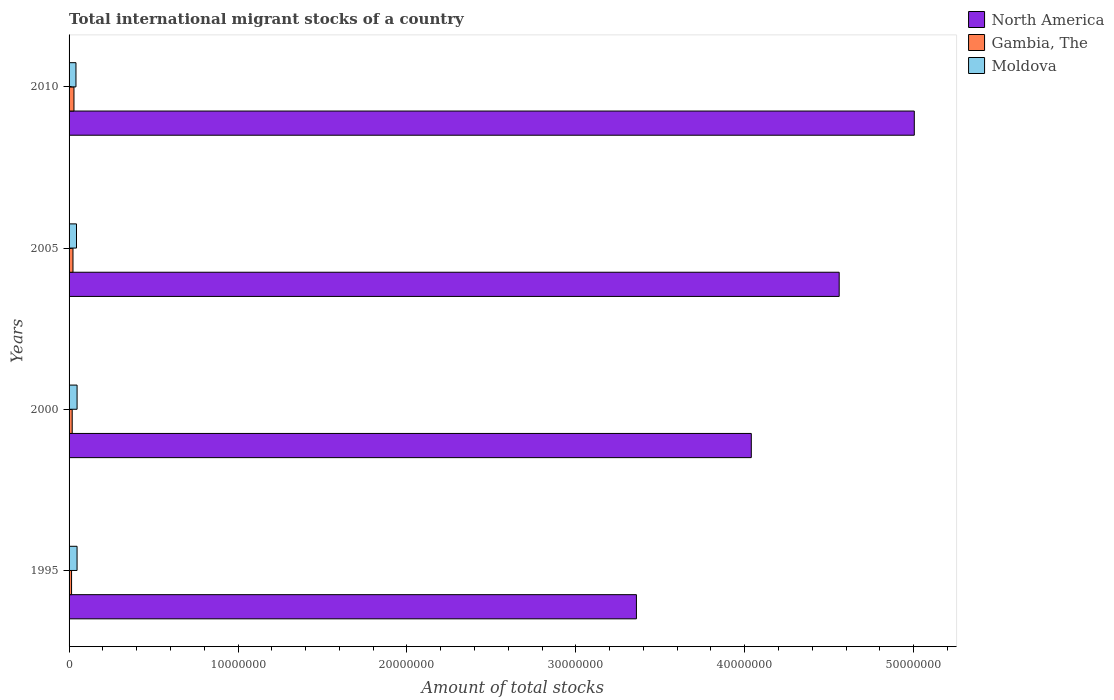How many different coloured bars are there?
Offer a terse response. 3. How many groups of bars are there?
Keep it short and to the point. 4. Are the number of bars per tick equal to the number of legend labels?
Your response must be concise. Yes. Are the number of bars on each tick of the Y-axis equal?
Your response must be concise. Yes. How many bars are there on the 3rd tick from the top?
Ensure brevity in your answer.  3. How many bars are there on the 2nd tick from the bottom?
Provide a short and direct response. 3. In how many cases, is the number of bars for a given year not equal to the number of legend labels?
Keep it short and to the point. 0. What is the amount of total stocks in in Moldova in 2000?
Your answer should be very brief. 4.74e+05. Across all years, what is the maximum amount of total stocks in in North America?
Your answer should be very brief. 5.00e+07. Across all years, what is the minimum amount of total stocks in in Moldova?
Provide a short and direct response. 4.08e+05. In which year was the amount of total stocks in in Gambia, The minimum?
Your response must be concise. 1995. What is the total amount of total stocks in in Moldova in the graph?
Keep it short and to the point. 1.80e+06. What is the difference between the amount of total stocks in in North America in 2005 and that in 2010?
Make the answer very short. -4.45e+06. What is the difference between the amount of total stocks in in Gambia, The in 2005 and the amount of total stocks in in Moldova in 2000?
Keep it short and to the point. -2.43e+05. What is the average amount of total stocks in in Moldova per year?
Your answer should be compact. 4.49e+05. In the year 2000, what is the difference between the amount of total stocks in in Gambia, The and amount of total stocks in in North America?
Your answer should be compact. -4.02e+07. What is the ratio of the amount of total stocks in in North America in 2000 to that in 2005?
Provide a short and direct response. 0.89. What is the difference between the highest and the second highest amount of total stocks in in North America?
Your response must be concise. 4.45e+06. What is the difference between the highest and the lowest amount of total stocks in in Moldova?
Offer a very short reply. 6.61e+04. What does the 2nd bar from the top in 2010 represents?
Your answer should be compact. Gambia, The. What does the 2nd bar from the bottom in 2010 represents?
Ensure brevity in your answer.  Gambia, The. How many bars are there?
Your response must be concise. 12. What is the difference between two consecutive major ticks on the X-axis?
Offer a terse response. 1.00e+07. Does the graph contain any zero values?
Ensure brevity in your answer.  No. Does the graph contain grids?
Keep it short and to the point. No. What is the title of the graph?
Keep it short and to the point. Total international migrant stocks of a country. Does "Iraq" appear as one of the legend labels in the graph?
Ensure brevity in your answer.  No. What is the label or title of the X-axis?
Keep it short and to the point. Amount of total stocks. What is the Amount of total stocks in North America in 1995?
Give a very brief answer. 3.36e+07. What is the Amount of total stocks in Gambia, The in 1995?
Provide a short and direct response. 1.48e+05. What is the Amount of total stocks in Moldova in 1995?
Keep it short and to the point. 4.73e+05. What is the Amount of total stocks in North America in 2000?
Your answer should be compact. 4.04e+07. What is the Amount of total stocks of Gambia, The in 2000?
Provide a succinct answer. 1.85e+05. What is the Amount of total stocks of Moldova in 2000?
Ensure brevity in your answer.  4.74e+05. What is the Amount of total stocks of North America in 2005?
Your answer should be compact. 4.56e+07. What is the Amount of total stocks of Gambia, The in 2005?
Provide a succinct answer. 2.32e+05. What is the Amount of total stocks of Moldova in 2005?
Your answer should be compact. 4.40e+05. What is the Amount of total stocks in North America in 2010?
Your answer should be compact. 5.00e+07. What is the Amount of total stocks of Gambia, The in 2010?
Your answer should be very brief. 2.90e+05. What is the Amount of total stocks of Moldova in 2010?
Offer a very short reply. 4.08e+05. Across all years, what is the maximum Amount of total stocks in North America?
Your answer should be compact. 5.00e+07. Across all years, what is the maximum Amount of total stocks in Gambia, The?
Ensure brevity in your answer.  2.90e+05. Across all years, what is the maximum Amount of total stocks in Moldova?
Your answer should be compact. 4.74e+05. Across all years, what is the minimum Amount of total stocks in North America?
Provide a succinct answer. 3.36e+07. Across all years, what is the minimum Amount of total stocks in Gambia, The?
Offer a terse response. 1.48e+05. Across all years, what is the minimum Amount of total stocks of Moldova?
Make the answer very short. 4.08e+05. What is the total Amount of total stocks of North America in the graph?
Your response must be concise. 1.70e+08. What is the total Amount of total stocks in Gambia, The in the graph?
Provide a succinct answer. 8.55e+05. What is the total Amount of total stocks in Moldova in the graph?
Your response must be concise. 1.80e+06. What is the difference between the Amount of total stocks in North America in 1995 and that in 2000?
Offer a terse response. -6.80e+06. What is the difference between the Amount of total stocks in Gambia, The in 1995 and that in 2000?
Keep it short and to the point. -3.72e+04. What is the difference between the Amount of total stocks in Moldova in 1995 and that in 2000?
Give a very brief answer. -1500. What is the difference between the Amount of total stocks of North America in 1995 and that in 2005?
Your response must be concise. -1.20e+07. What is the difference between the Amount of total stocks in Gambia, The in 1995 and that in 2005?
Your answer should be compact. -8.39e+04. What is the difference between the Amount of total stocks in Moldova in 1995 and that in 2005?
Ensure brevity in your answer.  3.28e+04. What is the difference between the Amount of total stocks in North America in 1995 and that in 2010?
Provide a short and direct response. -1.64e+07. What is the difference between the Amount of total stocks of Gambia, The in 1995 and that in 2010?
Provide a short and direct response. -1.42e+05. What is the difference between the Amount of total stocks of Moldova in 1995 and that in 2010?
Make the answer very short. 6.46e+04. What is the difference between the Amount of total stocks in North America in 2000 and that in 2005?
Keep it short and to the point. -5.20e+06. What is the difference between the Amount of total stocks of Gambia, The in 2000 and that in 2005?
Offer a very short reply. -4.66e+04. What is the difference between the Amount of total stocks in Moldova in 2000 and that in 2005?
Give a very brief answer. 3.43e+04. What is the difference between the Amount of total stocks of North America in 2000 and that in 2010?
Make the answer very short. -9.65e+06. What is the difference between the Amount of total stocks of Gambia, The in 2000 and that in 2010?
Give a very brief answer. -1.05e+05. What is the difference between the Amount of total stocks in Moldova in 2000 and that in 2010?
Your answer should be compact. 6.61e+04. What is the difference between the Amount of total stocks in North America in 2005 and that in 2010?
Your answer should be compact. -4.45e+06. What is the difference between the Amount of total stocks of Gambia, The in 2005 and that in 2010?
Your answer should be very brief. -5.84e+04. What is the difference between the Amount of total stocks of Moldova in 2005 and that in 2010?
Make the answer very short. 3.18e+04. What is the difference between the Amount of total stocks of North America in 1995 and the Amount of total stocks of Gambia, The in 2000?
Give a very brief answer. 3.34e+07. What is the difference between the Amount of total stocks of North America in 1995 and the Amount of total stocks of Moldova in 2000?
Provide a succinct answer. 3.31e+07. What is the difference between the Amount of total stocks of Gambia, The in 1995 and the Amount of total stocks of Moldova in 2000?
Provide a succinct answer. -3.27e+05. What is the difference between the Amount of total stocks in North America in 1995 and the Amount of total stocks in Gambia, The in 2005?
Your response must be concise. 3.34e+07. What is the difference between the Amount of total stocks of North America in 1995 and the Amount of total stocks of Moldova in 2005?
Offer a very short reply. 3.31e+07. What is the difference between the Amount of total stocks in Gambia, The in 1995 and the Amount of total stocks in Moldova in 2005?
Provide a succinct answer. -2.92e+05. What is the difference between the Amount of total stocks in North America in 1995 and the Amount of total stocks in Gambia, The in 2010?
Keep it short and to the point. 3.33e+07. What is the difference between the Amount of total stocks of North America in 1995 and the Amount of total stocks of Moldova in 2010?
Offer a very short reply. 3.32e+07. What is the difference between the Amount of total stocks of Gambia, The in 1995 and the Amount of total stocks of Moldova in 2010?
Give a very brief answer. -2.60e+05. What is the difference between the Amount of total stocks of North America in 2000 and the Amount of total stocks of Gambia, The in 2005?
Offer a very short reply. 4.02e+07. What is the difference between the Amount of total stocks in North America in 2000 and the Amount of total stocks in Moldova in 2005?
Your response must be concise. 3.99e+07. What is the difference between the Amount of total stocks of Gambia, The in 2000 and the Amount of total stocks of Moldova in 2005?
Give a very brief answer. -2.55e+05. What is the difference between the Amount of total stocks of North America in 2000 and the Amount of total stocks of Gambia, The in 2010?
Give a very brief answer. 4.01e+07. What is the difference between the Amount of total stocks of North America in 2000 and the Amount of total stocks of Moldova in 2010?
Your answer should be very brief. 4.00e+07. What is the difference between the Amount of total stocks of Gambia, The in 2000 and the Amount of total stocks of Moldova in 2010?
Ensure brevity in your answer.  -2.23e+05. What is the difference between the Amount of total stocks in North America in 2005 and the Amount of total stocks in Gambia, The in 2010?
Offer a terse response. 4.53e+07. What is the difference between the Amount of total stocks of North America in 2005 and the Amount of total stocks of Moldova in 2010?
Your answer should be very brief. 4.52e+07. What is the difference between the Amount of total stocks of Gambia, The in 2005 and the Amount of total stocks of Moldova in 2010?
Make the answer very short. -1.77e+05. What is the average Amount of total stocks in North America per year?
Keep it short and to the point. 4.24e+07. What is the average Amount of total stocks of Gambia, The per year?
Offer a very short reply. 2.14e+05. What is the average Amount of total stocks in Moldova per year?
Your response must be concise. 4.49e+05. In the year 1995, what is the difference between the Amount of total stocks of North America and Amount of total stocks of Gambia, The?
Make the answer very short. 3.34e+07. In the year 1995, what is the difference between the Amount of total stocks of North America and Amount of total stocks of Moldova?
Provide a short and direct response. 3.31e+07. In the year 1995, what is the difference between the Amount of total stocks in Gambia, The and Amount of total stocks in Moldova?
Your answer should be compact. -3.25e+05. In the year 2000, what is the difference between the Amount of total stocks in North America and Amount of total stocks in Gambia, The?
Your answer should be compact. 4.02e+07. In the year 2000, what is the difference between the Amount of total stocks in North America and Amount of total stocks in Moldova?
Give a very brief answer. 3.99e+07. In the year 2000, what is the difference between the Amount of total stocks of Gambia, The and Amount of total stocks of Moldova?
Keep it short and to the point. -2.89e+05. In the year 2005, what is the difference between the Amount of total stocks in North America and Amount of total stocks in Gambia, The?
Give a very brief answer. 4.54e+07. In the year 2005, what is the difference between the Amount of total stocks of North America and Amount of total stocks of Moldova?
Keep it short and to the point. 4.51e+07. In the year 2005, what is the difference between the Amount of total stocks in Gambia, The and Amount of total stocks in Moldova?
Offer a terse response. -2.08e+05. In the year 2010, what is the difference between the Amount of total stocks of North America and Amount of total stocks of Gambia, The?
Provide a short and direct response. 4.97e+07. In the year 2010, what is the difference between the Amount of total stocks of North America and Amount of total stocks of Moldova?
Give a very brief answer. 4.96e+07. In the year 2010, what is the difference between the Amount of total stocks of Gambia, The and Amount of total stocks of Moldova?
Keep it short and to the point. -1.18e+05. What is the ratio of the Amount of total stocks of North America in 1995 to that in 2000?
Offer a very short reply. 0.83. What is the ratio of the Amount of total stocks of Gambia, The in 1995 to that in 2000?
Ensure brevity in your answer.  0.8. What is the ratio of the Amount of total stocks of Moldova in 1995 to that in 2000?
Provide a short and direct response. 1. What is the ratio of the Amount of total stocks in North America in 1995 to that in 2005?
Make the answer very short. 0.74. What is the ratio of the Amount of total stocks of Gambia, The in 1995 to that in 2005?
Your response must be concise. 0.64. What is the ratio of the Amount of total stocks in Moldova in 1995 to that in 2005?
Your response must be concise. 1.07. What is the ratio of the Amount of total stocks of North America in 1995 to that in 2010?
Offer a very short reply. 0.67. What is the ratio of the Amount of total stocks in Gambia, The in 1995 to that in 2010?
Make the answer very short. 0.51. What is the ratio of the Amount of total stocks in Moldova in 1995 to that in 2010?
Offer a very short reply. 1.16. What is the ratio of the Amount of total stocks of North America in 2000 to that in 2005?
Keep it short and to the point. 0.89. What is the ratio of the Amount of total stocks in Gambia, The in 2000 to that in 2005?
Ensure brevity in your answer.  0.8. What is the ratio of the Amount of total stocks of Moldova in 2000 to that in 2005?
Offer a terse response. 1.08. What is the ratio of the Amount of total stocks of North America in 2000 to that in 2010?
Provide a succinct answer. 0.81. What is the ratio of the Amount of total stocks in Gambia, The in 2000 to that in 2010?
Give a very brief answer. 0.64. What is the ratio of the Amount of total stocks in Moldova in 2000 to that in 2010?
Ensure brevity in your answer.  1.16. What is the ratio of the Amount of total stocks in North America in 2005 to that in 2010?
Provide a short and direct response. 0.91. What is the ratio of the Amount of total stocks of Gambia, The in 2005 to that in 2010?
Your response must be concise. 0.8. What is the ratio of the Amount of total stocks in Moldova in 2005 to that in 2010?
Your response must be concise. 1.08. What is the difference between the highest and the second highest Amount of total stocks in North America?
Give a very brief answer. 4.45e+06. What is the difference between the highest and the second highest Amount of total stocks of Gambia, The?
Provide a succinct answer. 5.84e+04. What is the difference between the highest and the second highest Amount of total stocks in Moldova?
Your answer should be compact. 1500. What is the difference between the highest and the lowest Amount of total stocks in North America?
Offer a very short reply. 1.64e+07. What is the difference between the highest and the lowest Amount of total stocks of Gambia, The?
Provide a succinct answer. 1.42e+05. What is the difference between the highest and the lowest Amount of total stocks in Moldova?
Provide a succinct answer. 6.61e+04. 